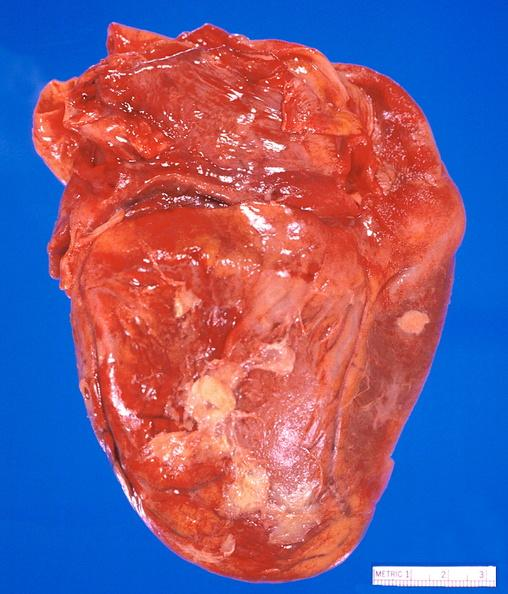s cardiovascular present?
Answer the question using a single word or phrase. Yes 